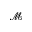Convert formula to latex. <formula><loc_0><loc_0><loc_500><loc_500>\mathcal { M }</formula> 